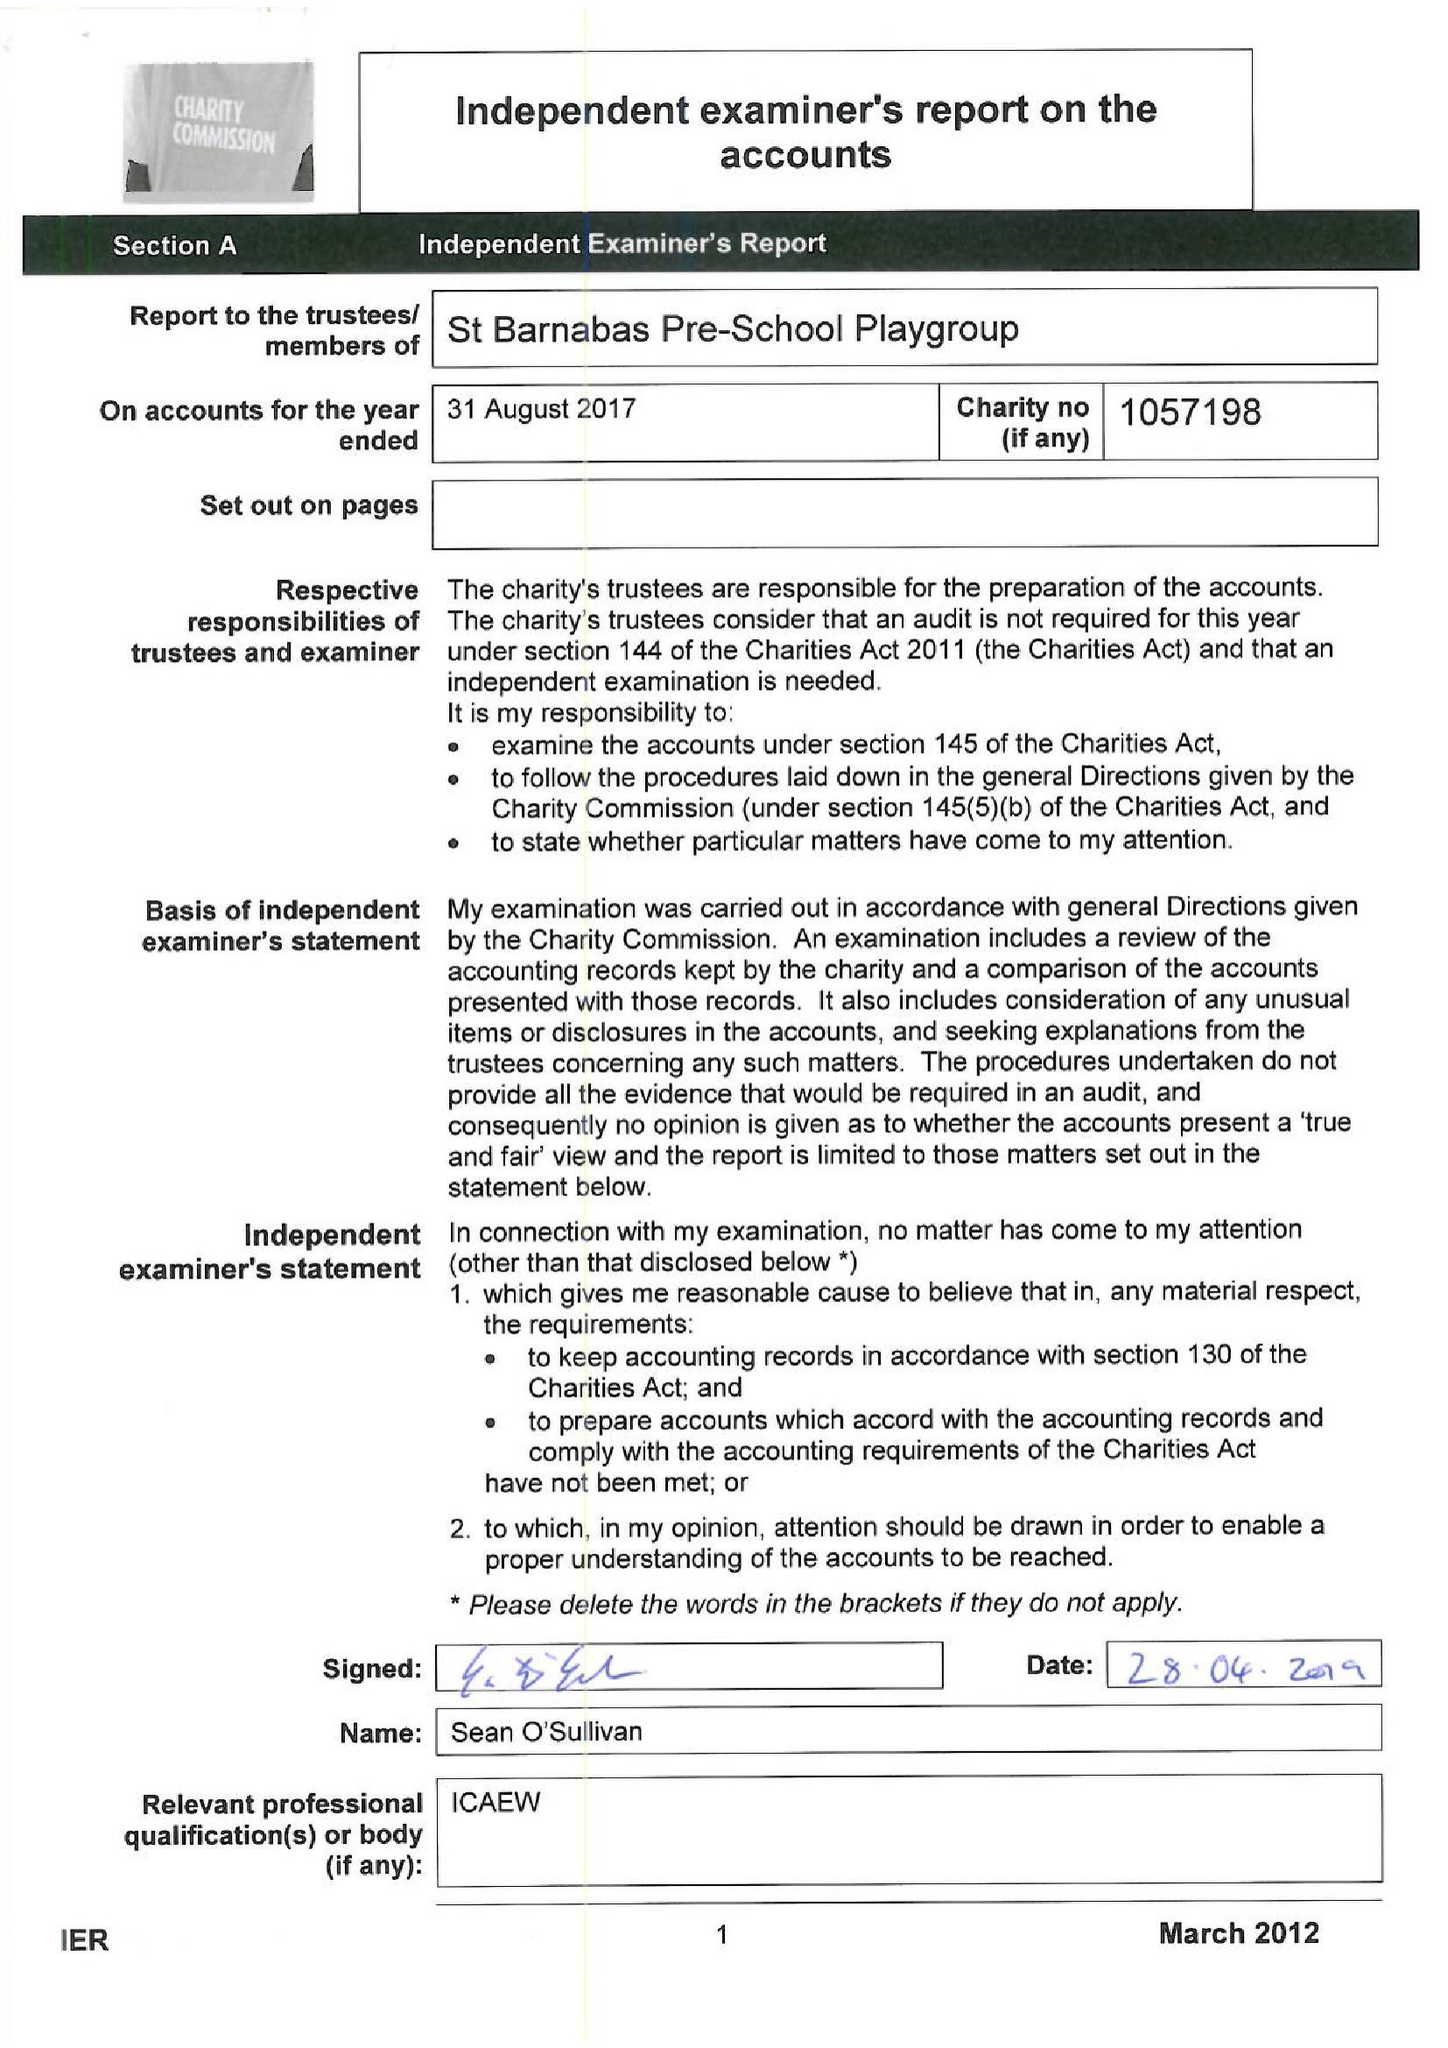What is the value for the income_annually_in_british_pounds?
Answer the question using a single word or phrase. 61148.00 